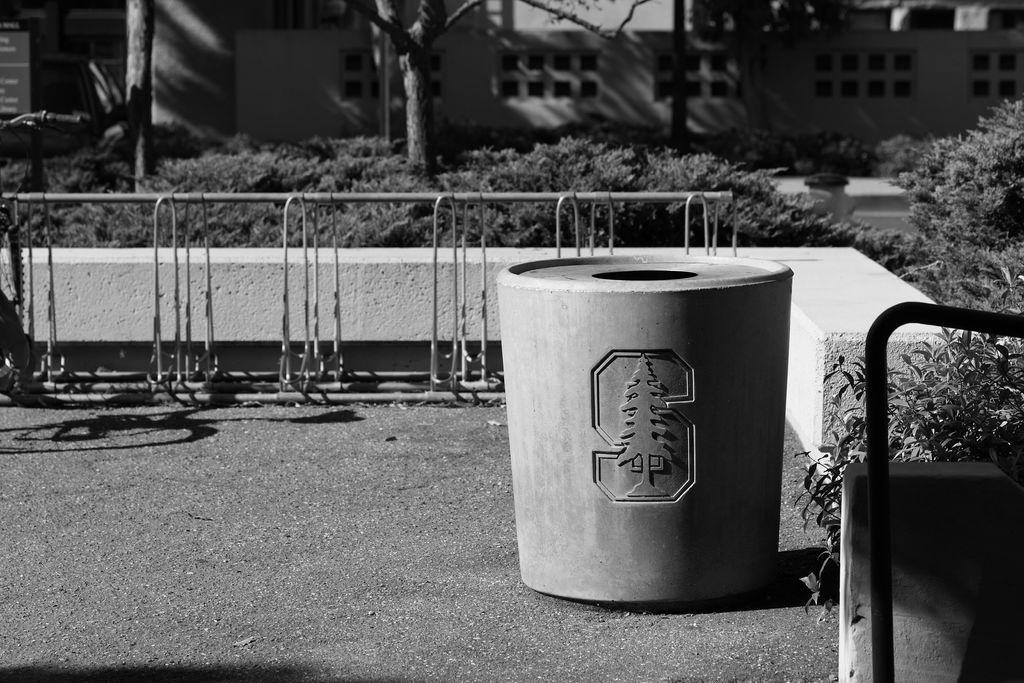Can you describe this image briefly? This is a black and white image. In this image we can see a container placed on the ground. We can also see a fence, plants, bark of the trees and a building with windows. 